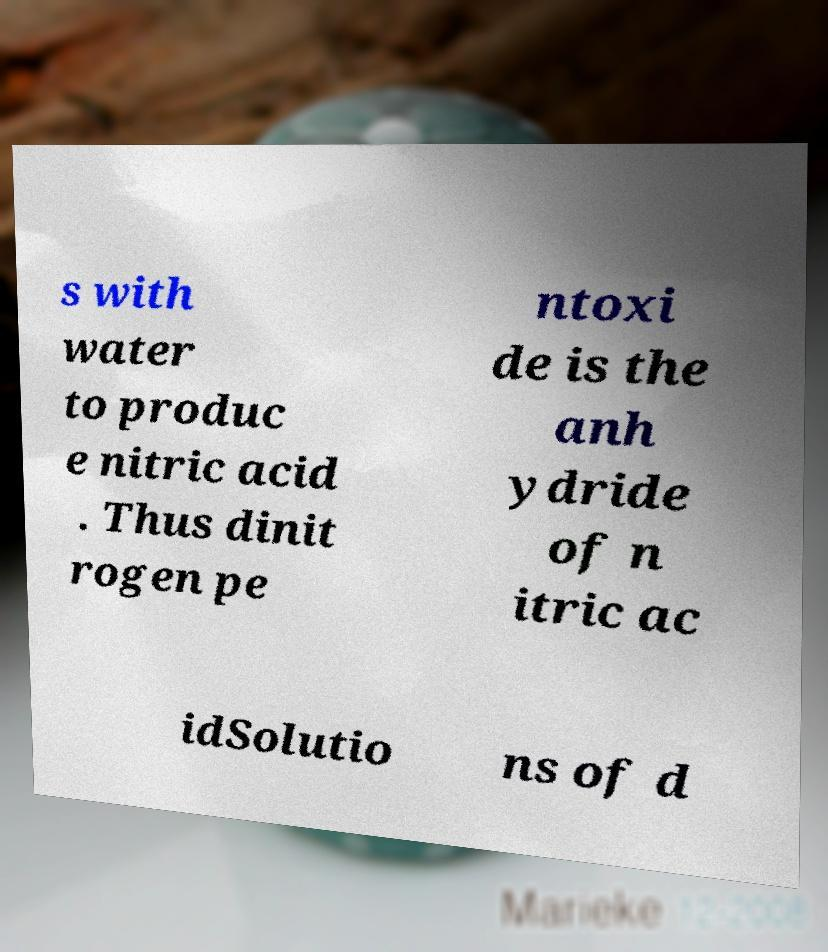For documentation purposes, I need the text within this image transcribed. Could you provide that? s with water to produc e nitric acid . Thus dinit rogen pe ntoxi de is the anh ydride of n itric ac idSolutio ns of d 